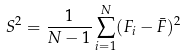Convert formula to latex. <formula><loc_0><loc_0><loc_500><loc_500>S ^ { 2 } = \frac { 1 } { N - 1 } \sum _ { i = 1 } ^ { N } ( F _ { i } - \bar { F } ) ^ { 2 }</formula> 